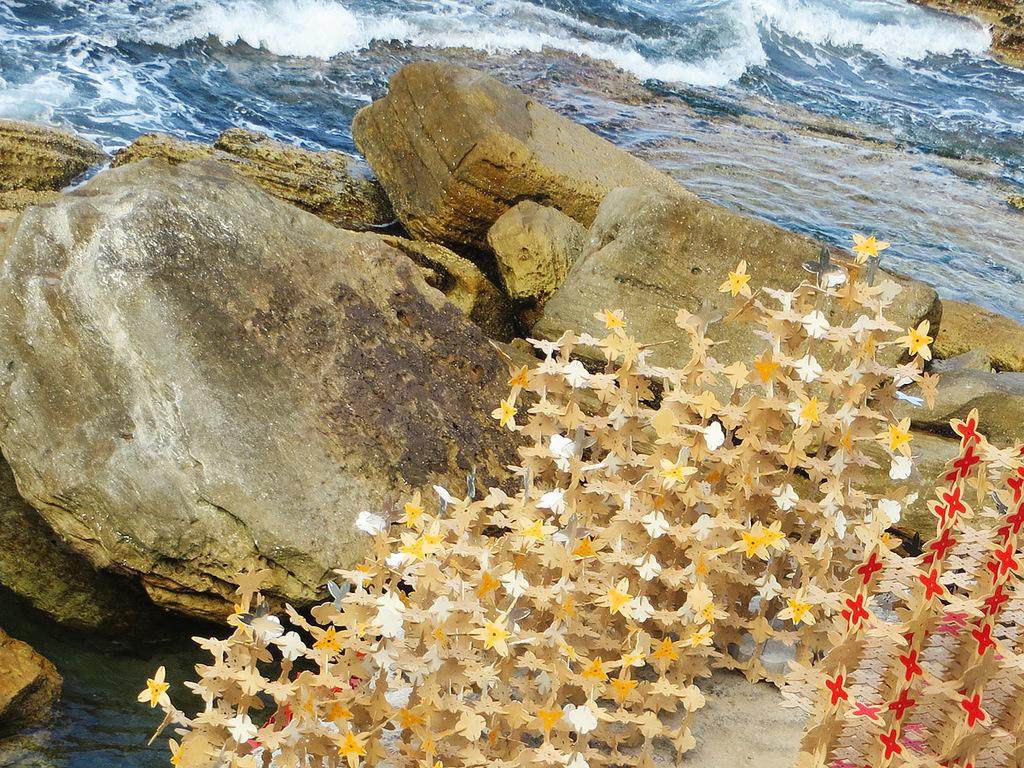What is the main subject of the image? The main subject of the image is some craft. What type of natural elements can be seen in the image? There are stones and water visible in the image. Who is the creator of the loaf in the image? There is no loaf present in the image. How old is the daughter in the image? There is no daughter present in the image. 